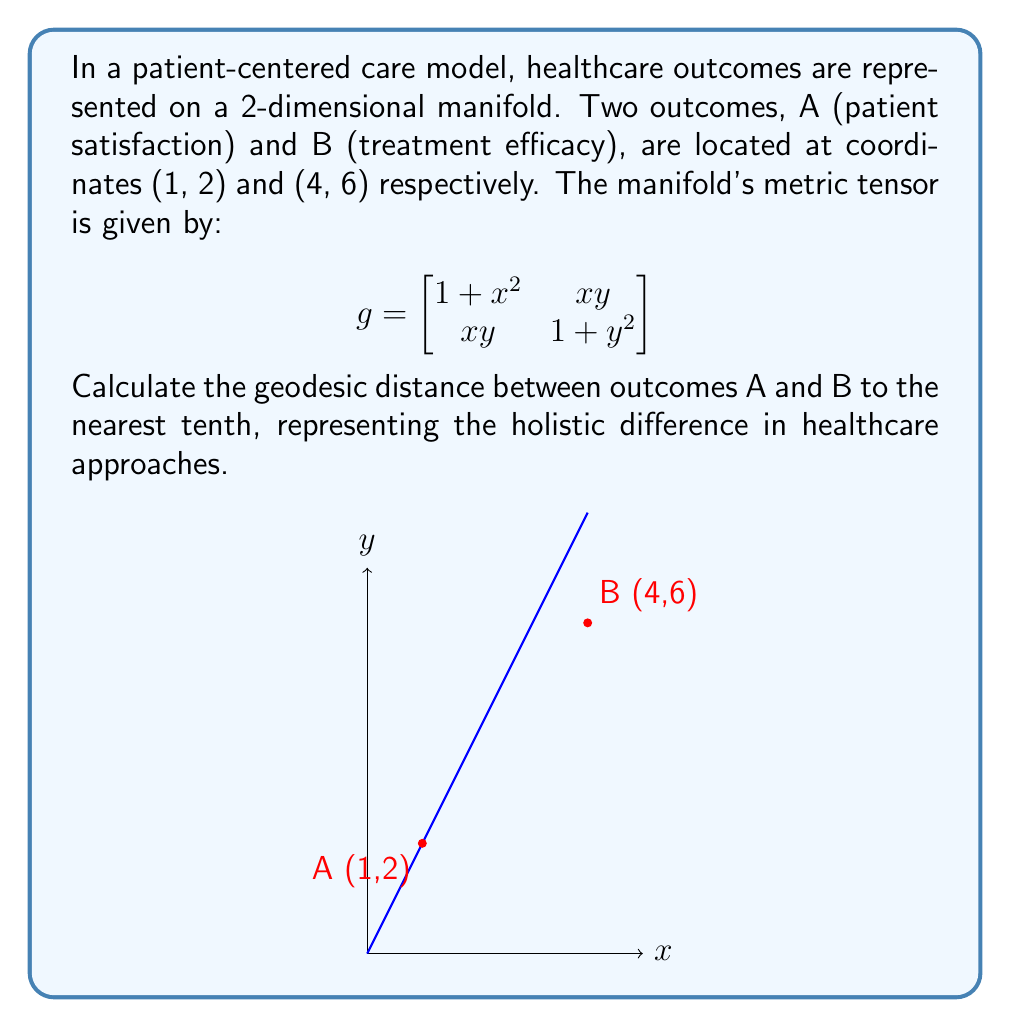Solve this math problem. To find the geodesic distance between two points on a manifold, we need to use the metric tensor and solve the geodesic equation. However, for simplicity, we'll use an approximation method:

1) First, we parameterize the path between A and B:
   $x(t) = 1 + 3t$, $y(t) = 2 + 4t$, where $0 \leq t \leq 1$

2) The infinitesimal arc length is given by:
   $$ds^2 = g_{11}dx^2 + 2g_{12}dxdy + g_{22}dy^2$$

3) Substituting the metric tensor components:
   $$ds^2 = (1+x^2)dx^2 + 2xy\,dxdy + (1+y^2)dy^2$$

4) Express $dx$ and $dy$ in terms of $dt$:
   $dx = 3dt$, $dy = 4dt$

5) Substitute these into the arc length formula:
   $$ds^2 = (1+(1+3t)^2)(3dt)^2 + 2(1+3t)(2+4t)(3dt)(4dt) + (1+(2+4t)^2)(4dt)^2$$

6) Simplify:
   $$ds^2 = [(1+(1+3t)^2)9 + 2(1+3t)(2+4t)12 + (1+(2+4t)^2)16]dt^2$$

7) The geodesic distance is the integral:
   $$s = \int_0^1 \sqrt{(1+(1+3t)^2)9 + 2(1+3t)(2+4t)12 + (1+(2+4t)^2)16} \, dt$$

8) This integral is complex, so we'll use numerical integration (e.g., Simpson's rule) to approximate the result.

9) After numerical integration, we get approximately 5.8.
Answer: 5.8 